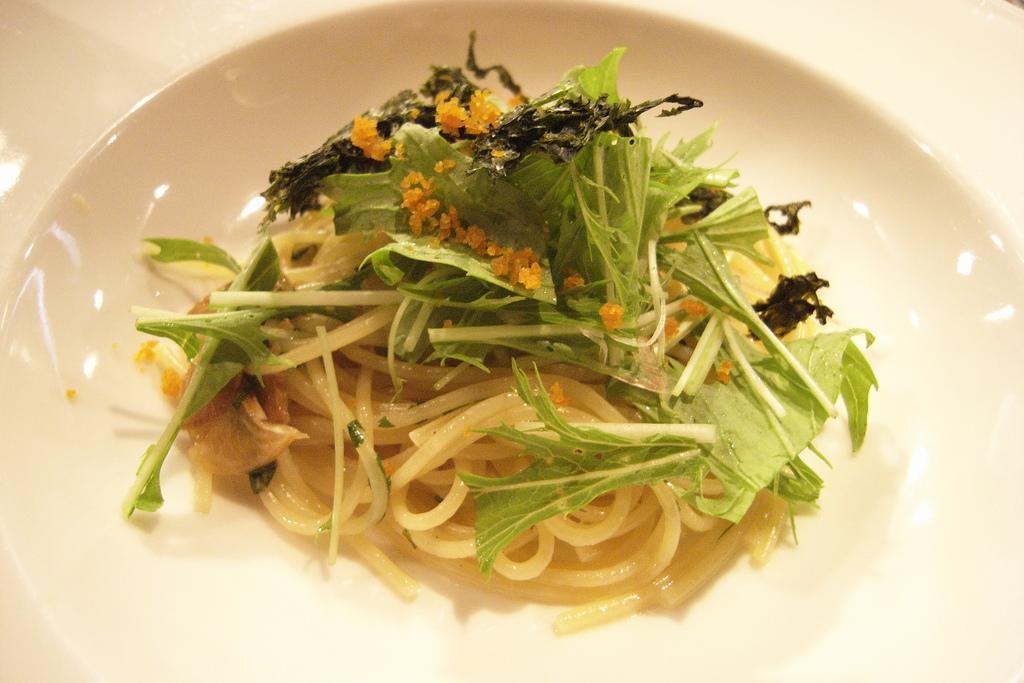In one or two sentences, can you explain what this image depicts? In this image there is a plate. There is food on the plate. There is spaghetti, onions and green leafy vegetables in the food. 